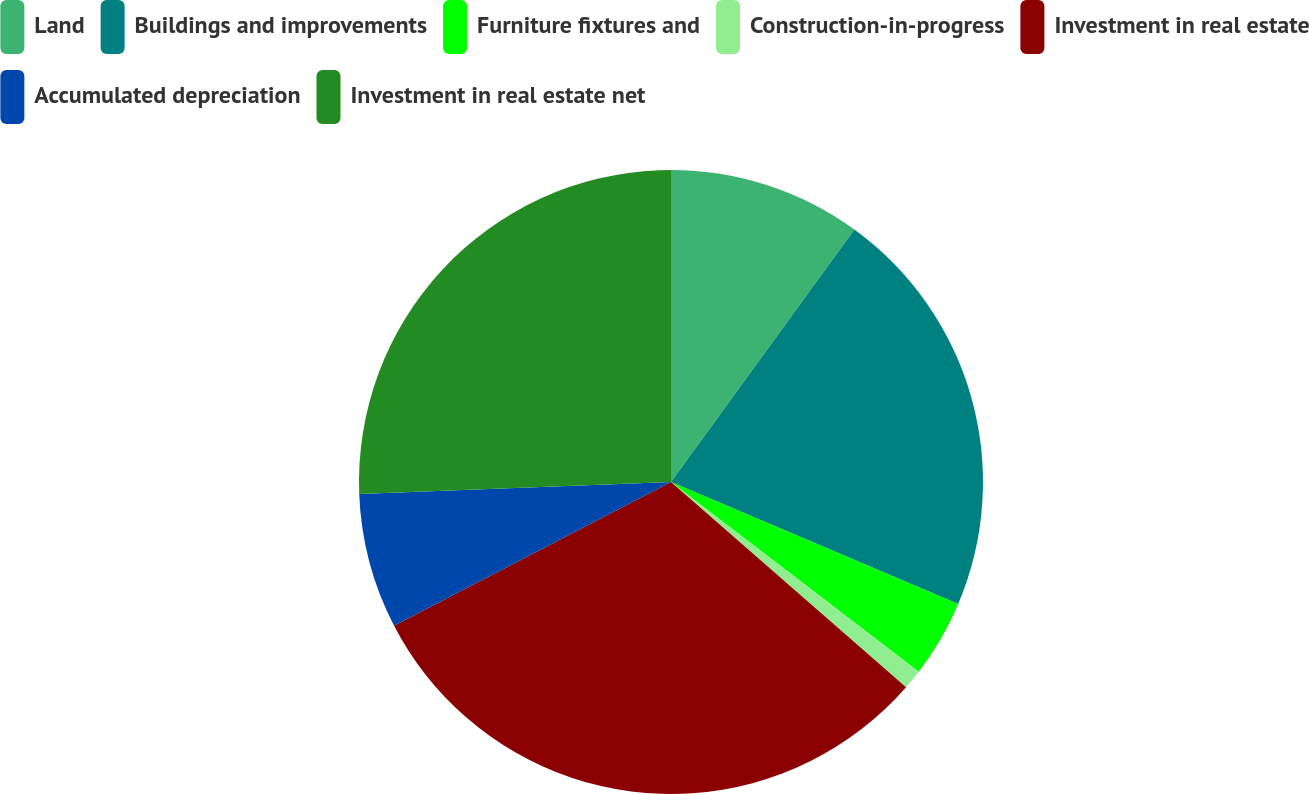Convert chart. <chart><loc_0><loc_0><loc_500><loc_500><pie_chart><fcel>Land<fcel>Buildings and improvements<fcel>Furniture fixtures and<fcel>Construction-in-progress<fcel>Investment in real estate<fcel>Accumulated depreciation<fcel>Investment in real estate net<nl><fcel>10.0%<fcel>21.39%<fcel>4.01%<fcel>1.02%<fcel>30.96%<fcel>7.01%<fcel>25.61%<nl></chart> 